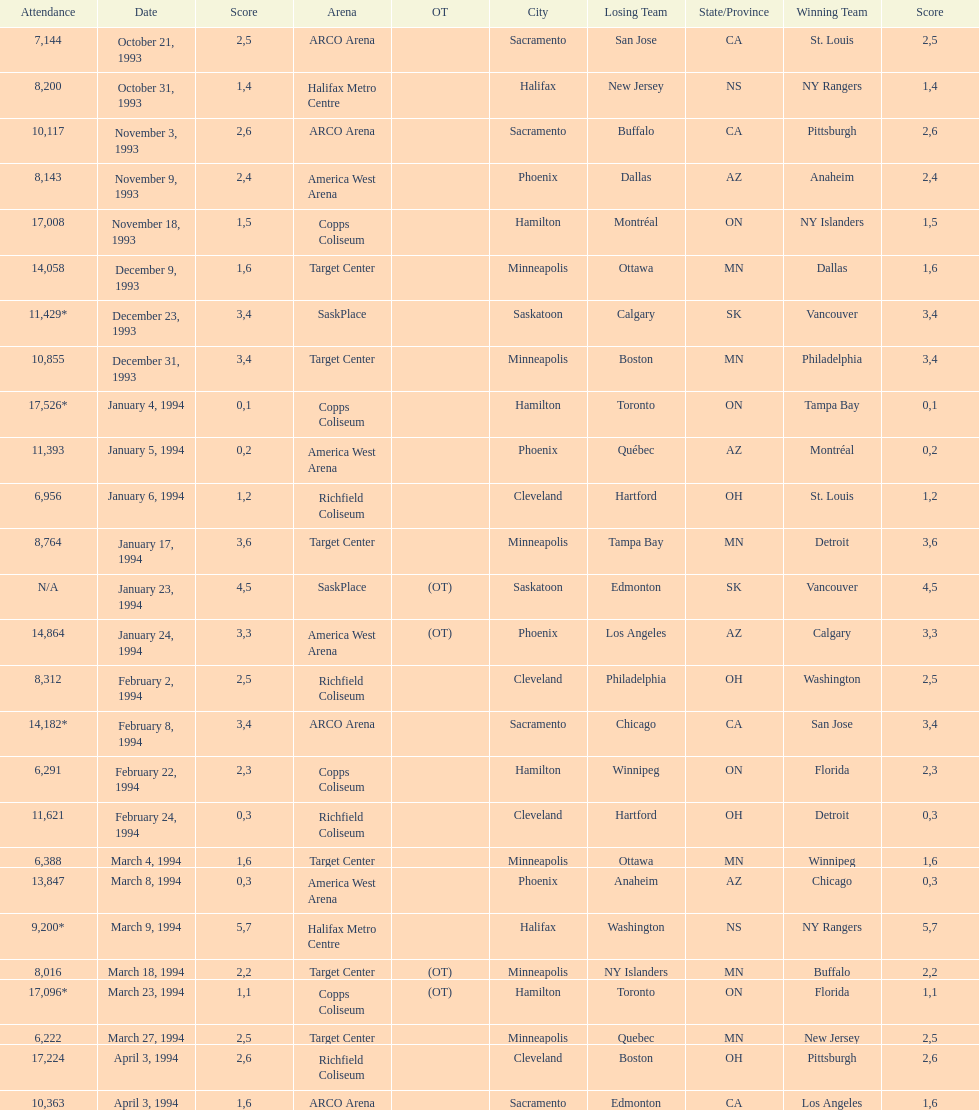When was the first neutral site game to be won by tampa bay? January 4, 1994. 